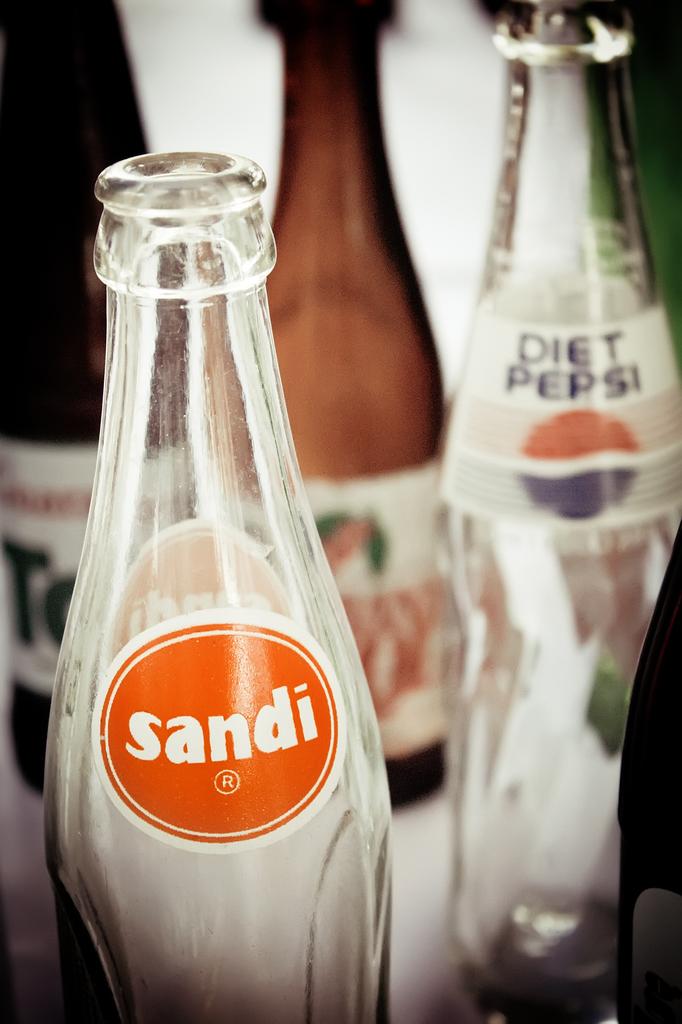What brand of soda on the right?
Provide a succinct answer. Diet pepsi. 